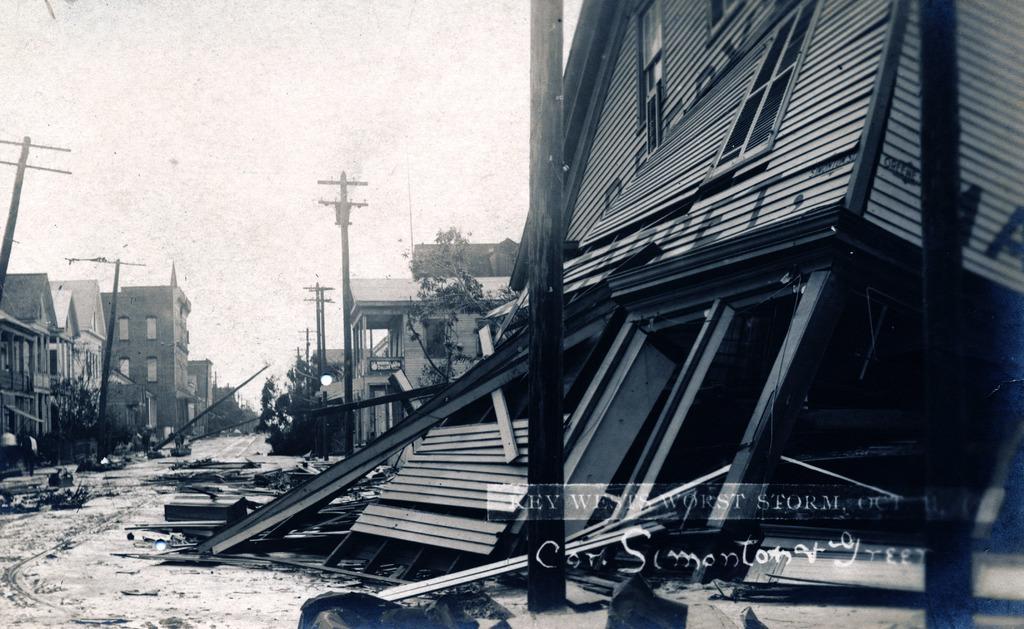Could you give a brief overview of what you see in this image? This is black and white picture,we can see buildings,trees,current poles and sky. Bottom of the image we can see watermark. 